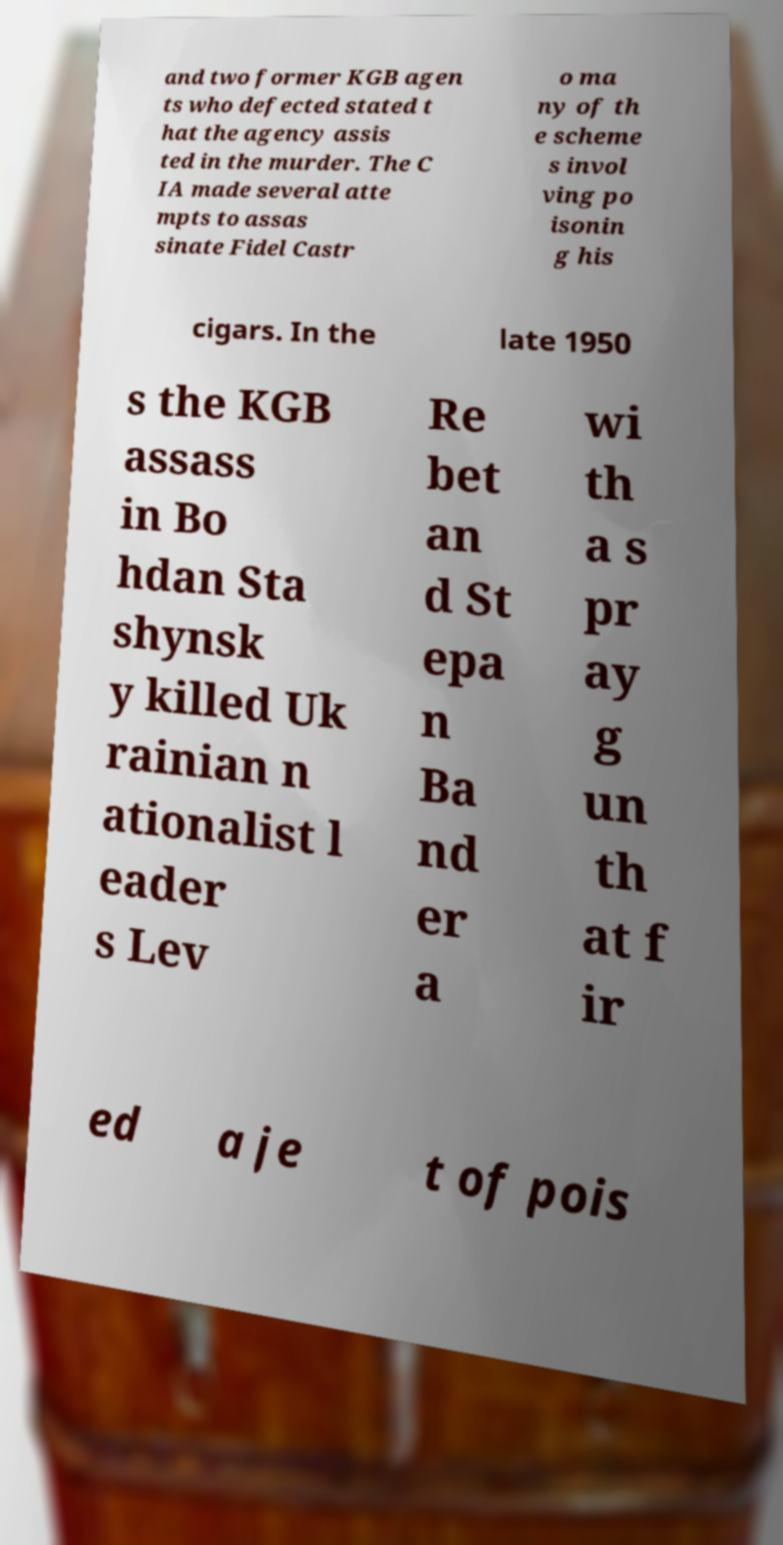Please identify and transcribe the text found in this image. and two former KGB agen ts who defected stated t hat the agency assis ted in the murder. The C IA made several atte mpts to assas sinate Fidel Castr o ma ny of th e scheme s invol ving po isonin g his cigars. In the late 1950 s the KGB assass in Bo hdan Sta shynsk y killed Uk rainian n ationalist l eader s Lev Re bet an d St epa n Ba nd er a wi th a s pr ay g un th at f ir ed a je t of pois 